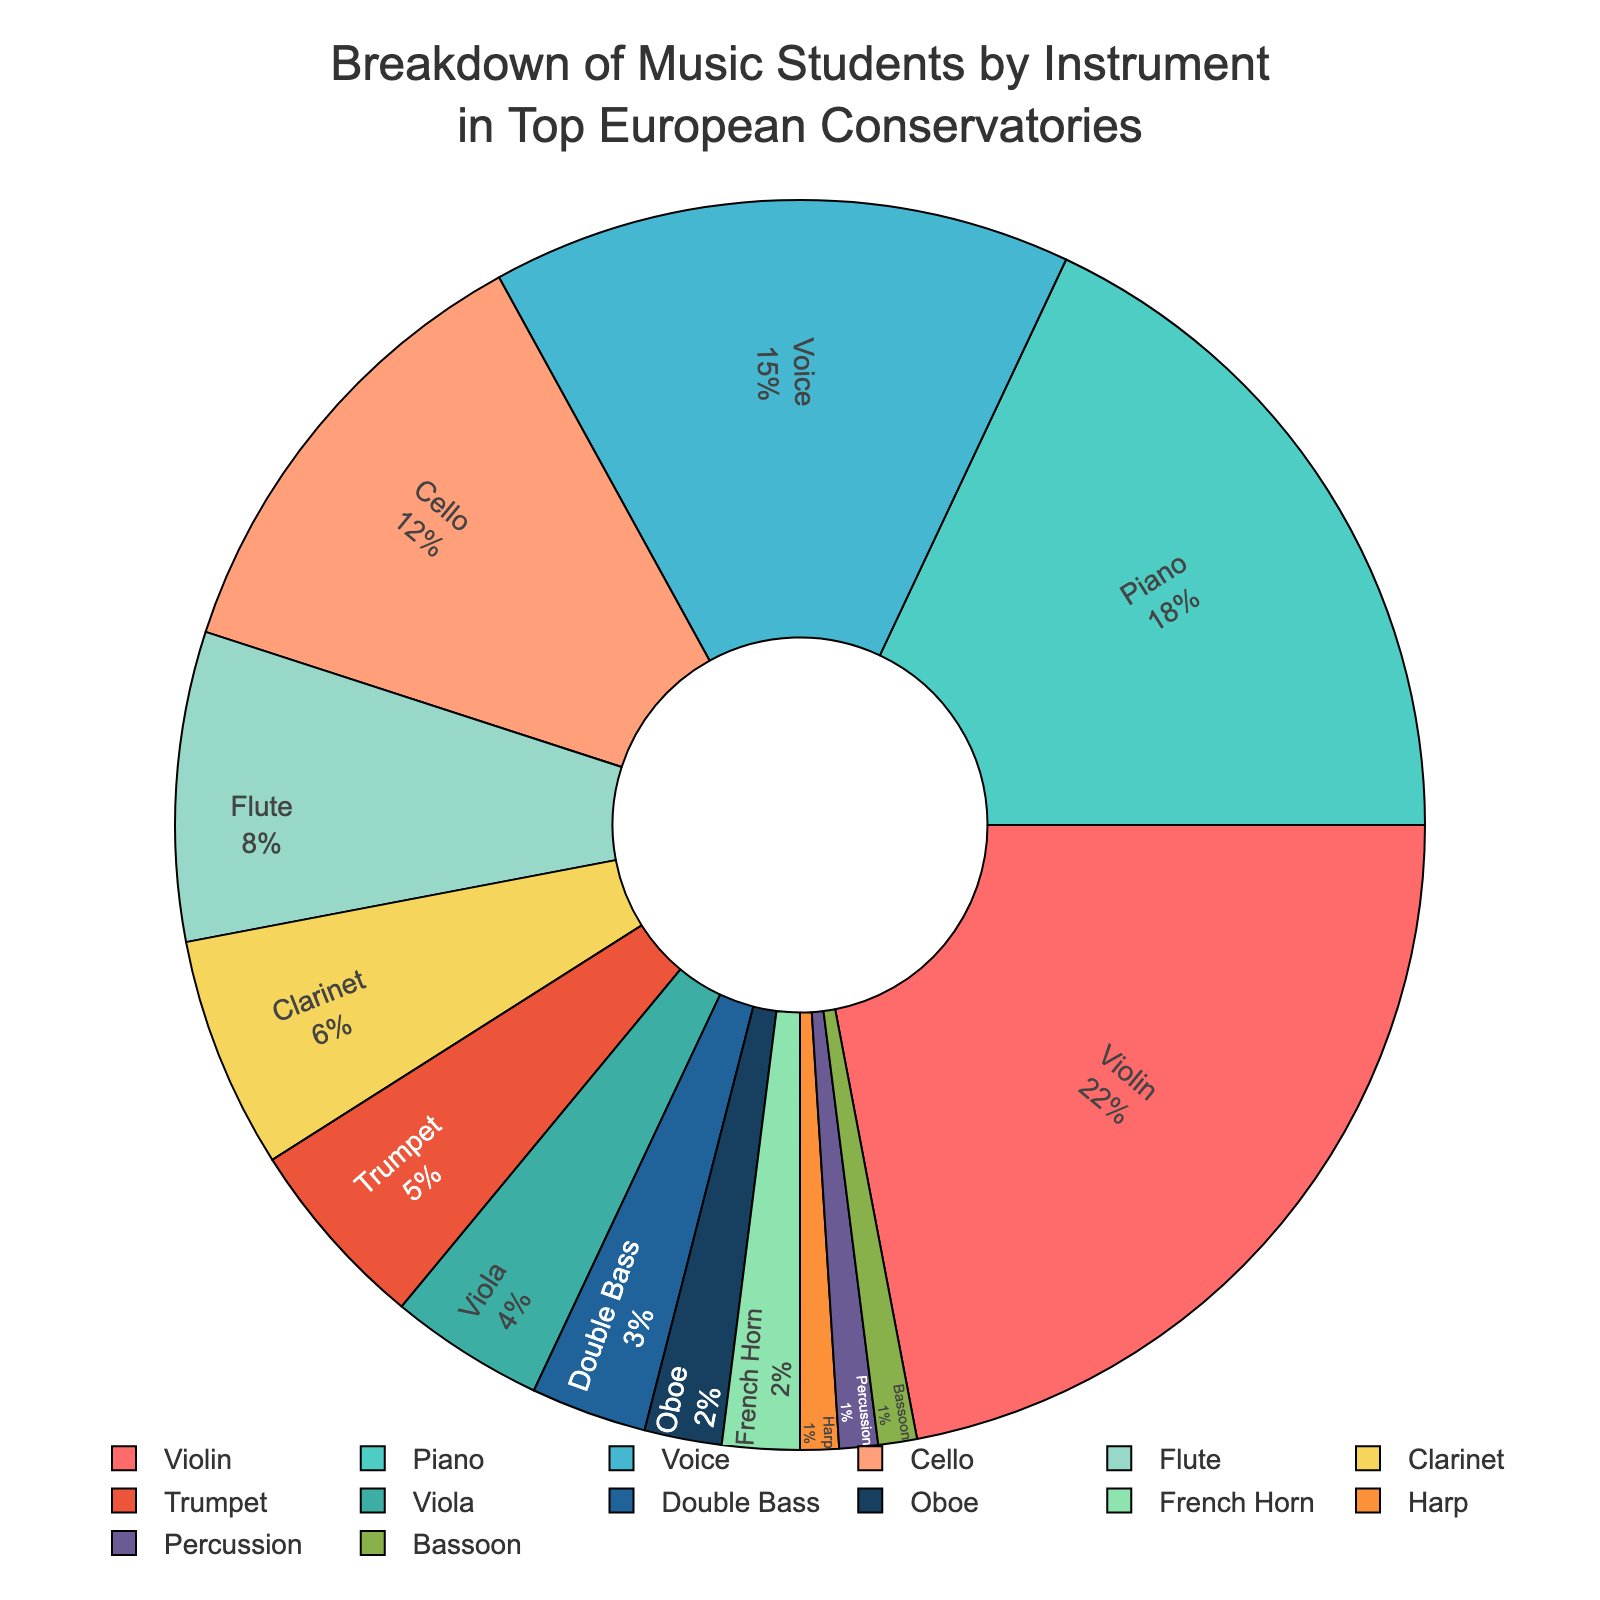What percentage of students play the Violin? The figure shows the breakdown by instrument and indicates that Violin has the percentage of 22%.
Answer: 22% Which instrument has the smallest proportion of students? According to the figure, Harp, Percussion, and Bassoon each have the lowest percentage of 1%.
Answer: Harp, Percussion, and Bassoon Are there more Piano or Cello students? How many more? The figure shows that Piano has 18% and Cello has 12%. The difference is 18% - 12% = 6%.
Answer: Piano by 6% Which three instruments have approximately the same percentage of students, and what is that percentage? The figure indicates that Oboe, French Horn, and Harp each have 2%, 2%, and 1% respectively, adding up to 3%. They are close in percentage values.
Answer: Oboe, French Horn, and Harp; all have around 2% Are there more students playing the Trumpet or the Viola? By how much? According to the figure, Trumpet has 5% and Viola has 4%. The difference is 5% - 4% = 1%.
Answer: Trumpet by 1% What is the combined percentage of students playing Clarinet, Trumpet, and Flute? Clarinet has 6%, Trumpet has 5%, and Flute has 8%. Summing these gives 6% + 5% + 8% = 19%.
Answer: 19% Which instrument has a higher percentage of students: Cello or Double Bass? The figure shows that Cello has 12% and Double Bass has 3%.
Answer: Cello How does the percentage of Voice students compare to that of Piano? Voice students account for 15% while Piano students account for 18%, indicating that there are fewer Voice students compared to Piano students.
Answer: Fewer Voice students (by 3%) Which has a higher percentage: students playing Brass instruments (Trumpet, French Horn) or Woodwind instruments (Flute, Clarinet, Oboe, Bassoon)? Summing the percentages for the Brass instruments (Trumpet 5%, French Horn 2%) gives 7%. Summing the percentages for the Woodwind instruments (Flute 8%, Clarinet 6%, Oboe 2%, Bassoon 1%) gives 17%.
Answer: Woodwind instruments What percentage of students play either Violin, Cello, or Piano? Violin has 22%, Cello has 12%, and Piano has 18%. Summing these, 22% + 12% + 18% = 52%.
Answer: 52% 